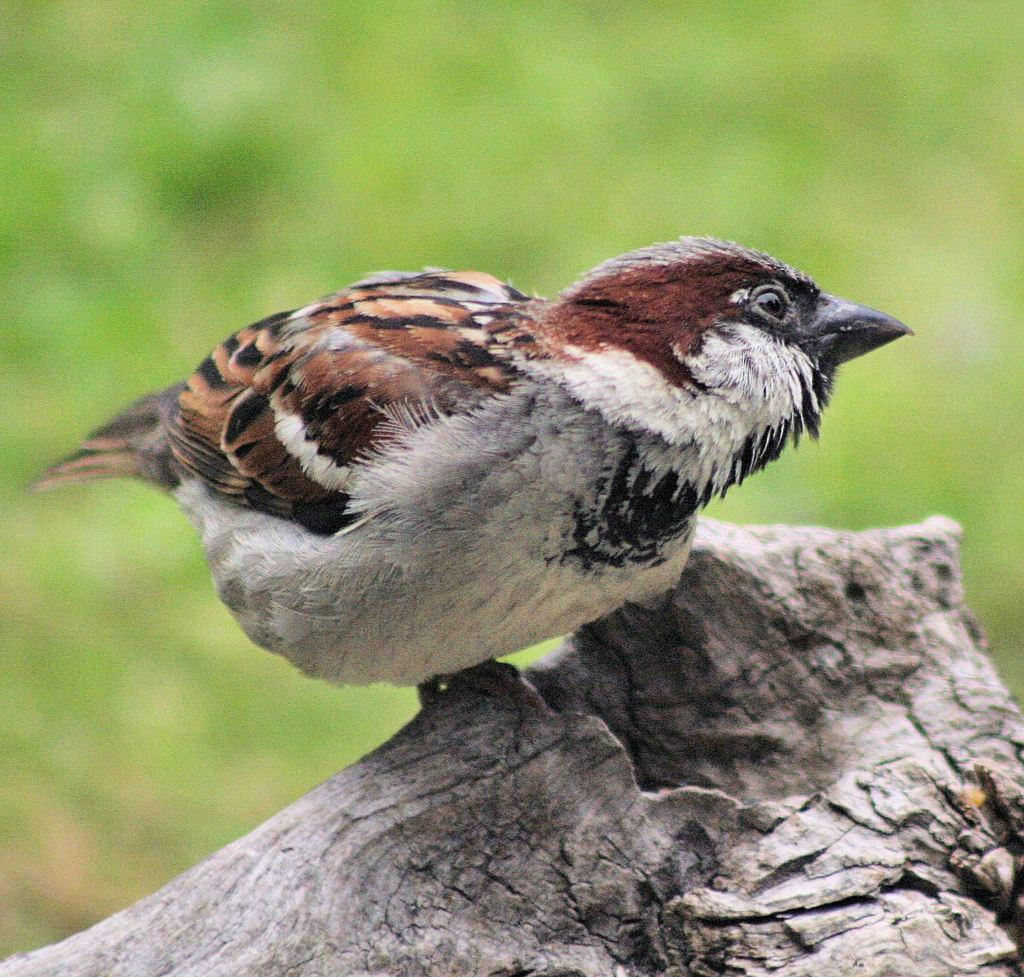What type of animal is present in the image? There is a bird in the image. Where is the bird located? The bird is on a wooden object. Can you describe the background of the image? The background of the image is blurred. What type of vegetation can be seen in the background? There is greenery visible in the background. How many lettuce leaves can be seen in the image? There is no lettuce present in the image. What type of currency is visible in the image? There is no currency, such as a cent, present in the image. 